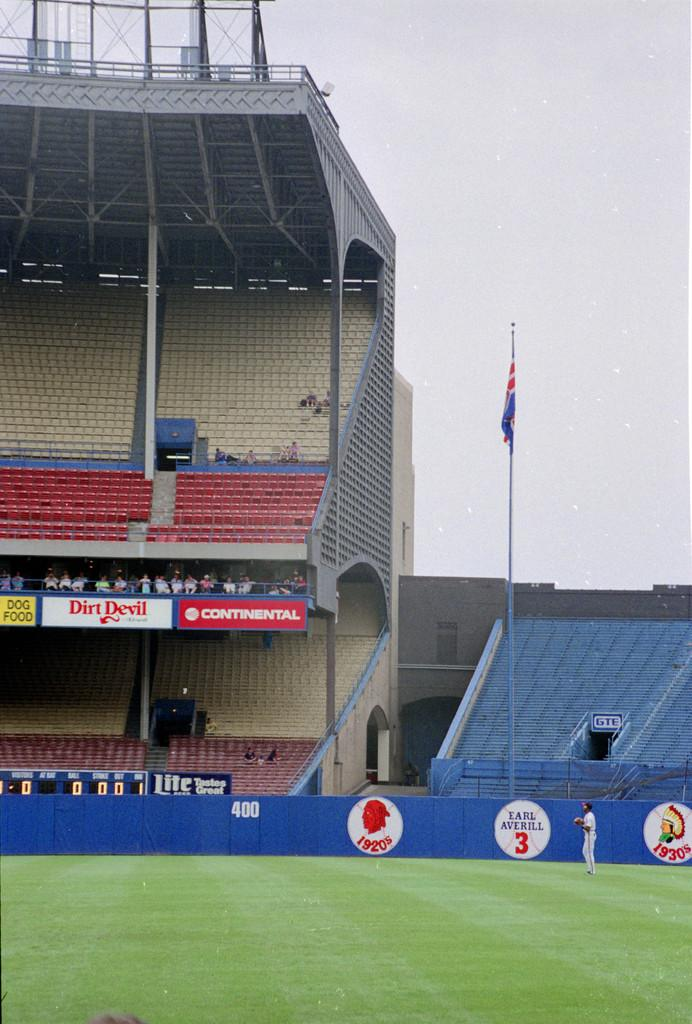<image>
Provide a brief description of the given image. a blue wall with the number 3 on a baseball graphic 